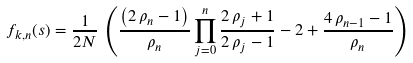Convert formula to latex. <formula><loc_0><loc_0><loc_500><loc_500>f _ { k , n } ( s ) = \frac { 1 } { 2 N } \, \left ( \frac { \left ( 2 \, \rho _ { n } - 1 \right ) } { \rho _ { n } } \prod _ { j = 0 } ^ { n } { \frac { 2 \, \rho _ { j } + 1 } { 2 \, \rho _ { j } - 1 } } - 2 + { \frac { 4 \, \rho _ { n - 1 } - 1 } { \rho _ { n } } } \right )</formula> 